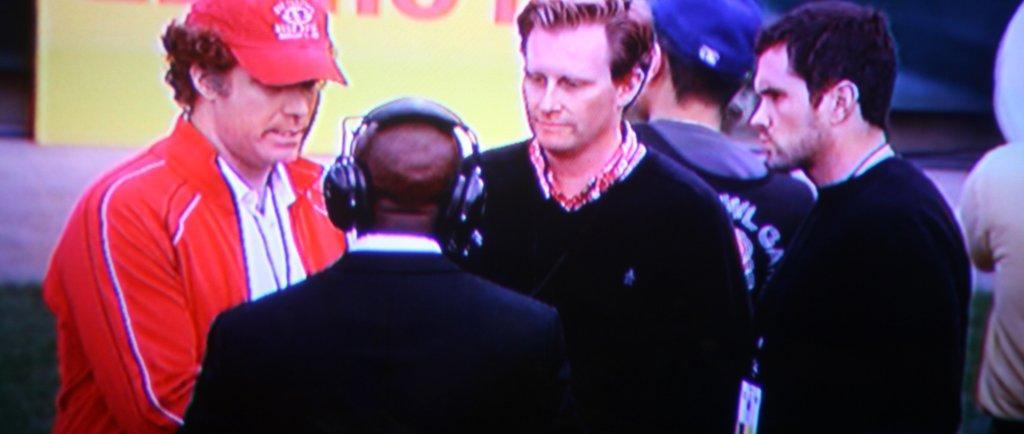Could you give a brief overview of what you see in this image? In this image, we can see a group of people. Few are wearing caps. In the middle of the image, a person is wearing headphones. Background we can see a hoarding. 